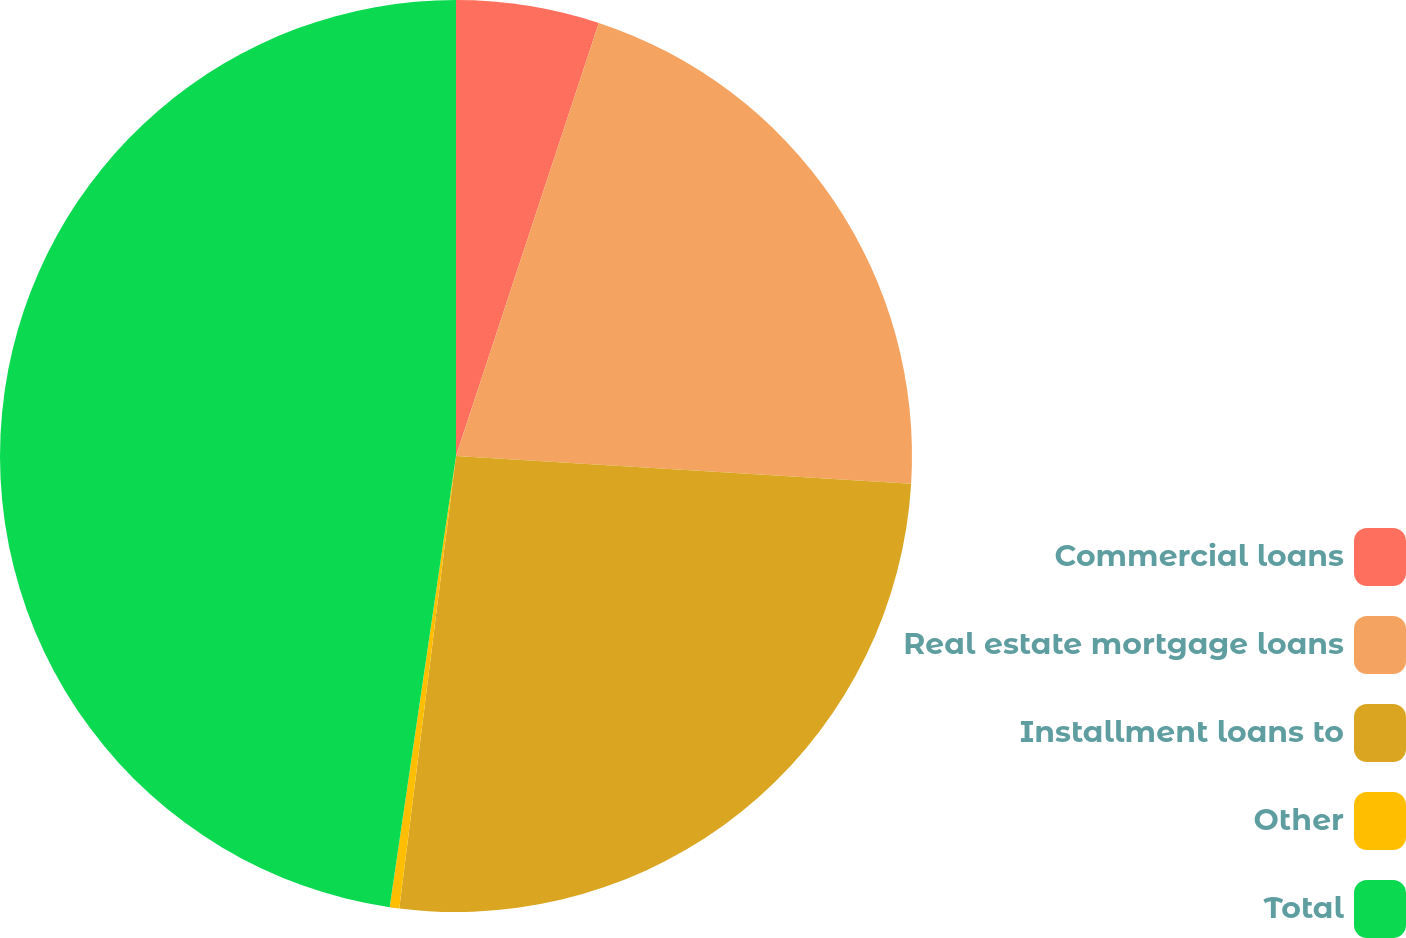<chart> <loc_0><loc_0><loc_500><loc_500><pie_chart><fcel>Commercial loans<fcel>Real estate mortgage loans<fcel>Installment loans to<fcel>Other<fcel>Total<nl><fcel>5.07%<fcel>20.9%<fcel>26.02%<fcel>0.34%<fcel>47.68%<nl></chart> 